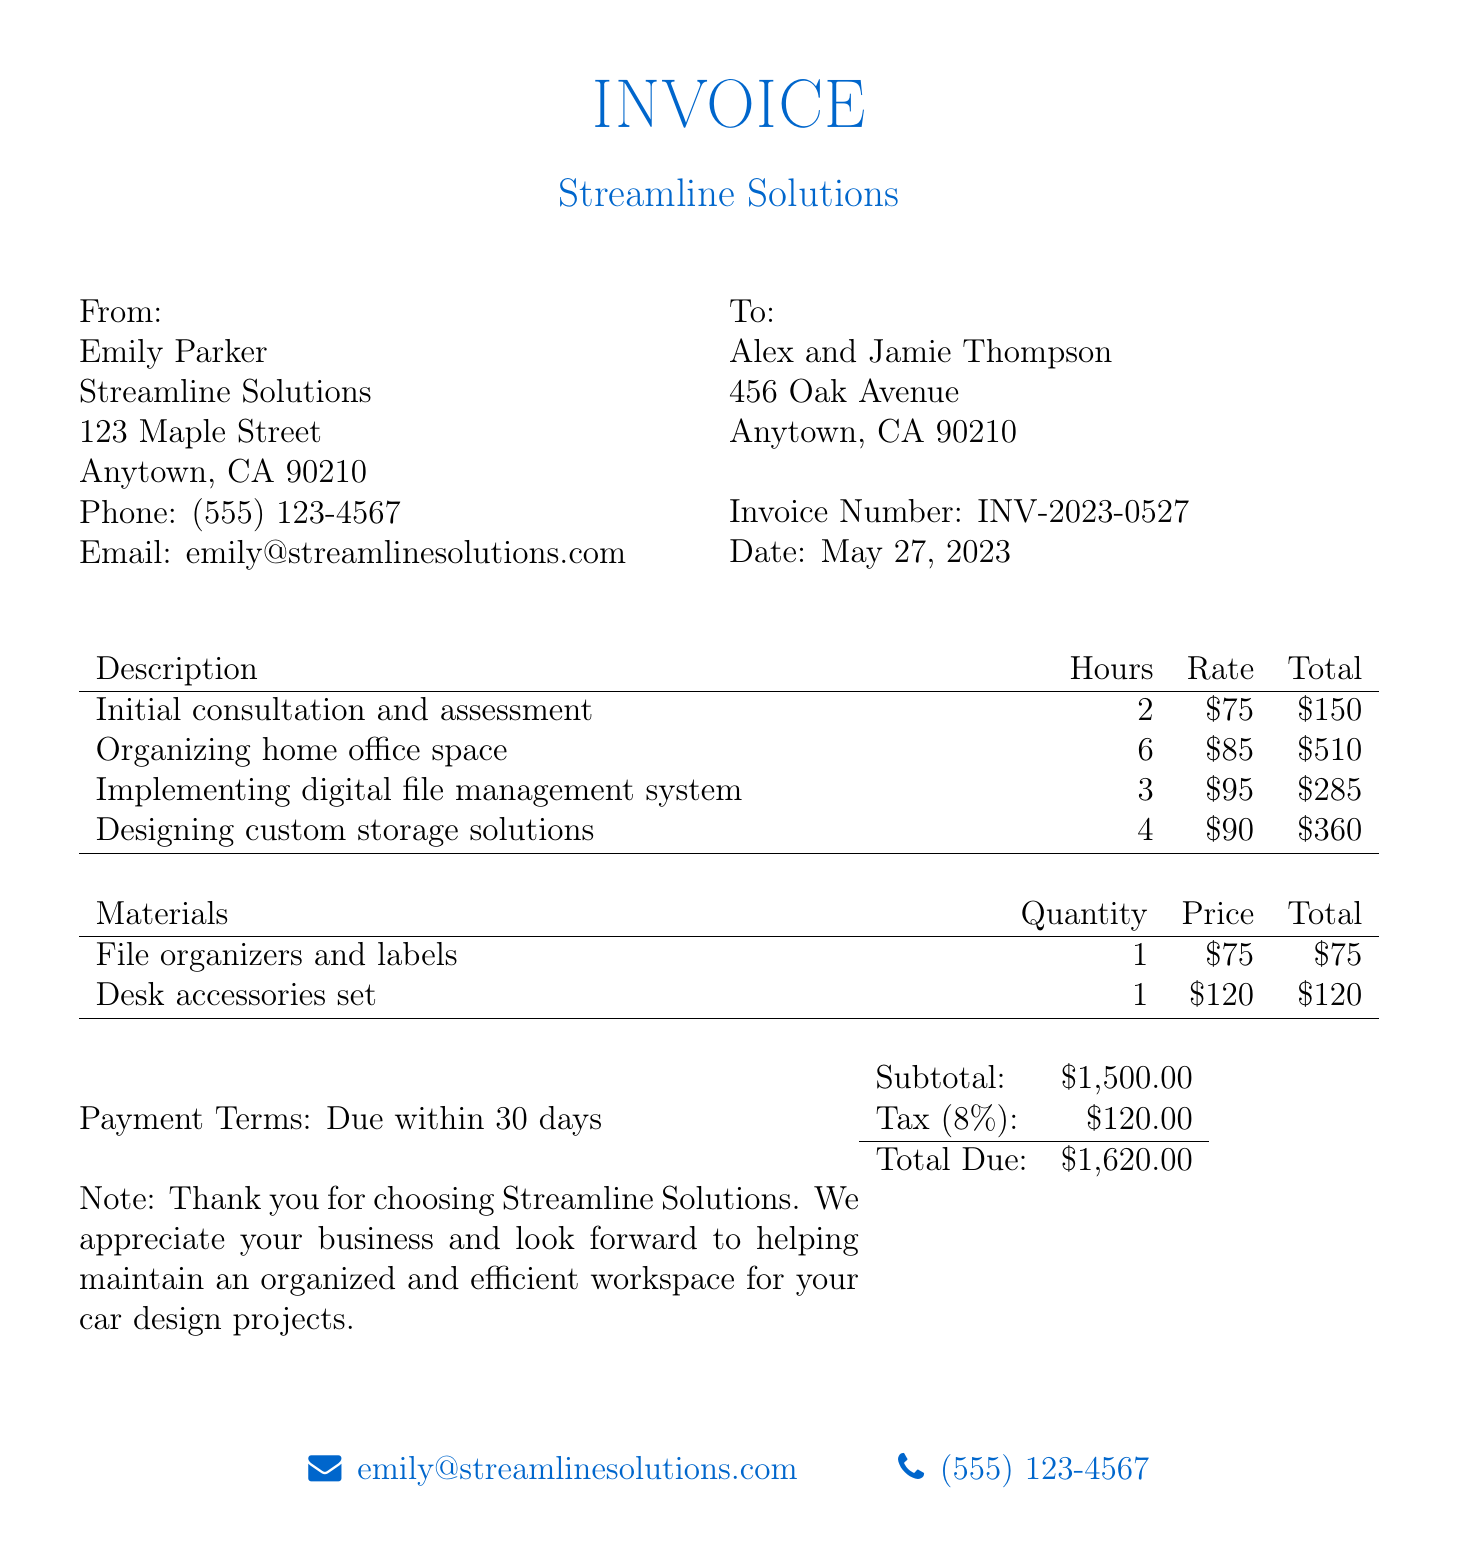What is the invoice number? The invoice number is a unique identifier for the bill, found in the document.
Answer: INV-2023-0527 Who is the service provider? The service provider is the company or individual that provided the organizing services.
Answer: Emily Parker How many hours were spent organizing the home office space? The document provides a breakdown of hours for each service, including organizing the home office.
Answer: 6 What is the total due amount? The total due amount is presented at the end of the invoice and combines all services and materials.
Answer: $1,620.00 What is the rate for implementing a digital file management system? The rate is outlined next to the service description and is part of the pricing details.
Answer: $95 What materials were purchased for organizing? The document lists specific materials that were acquired for the service.
Answer: File organizers and labels, Desk accessories set How much is the tax applied to the invoice? The tax is calculated based on the subtotal and shown in a separate line.
Answer: $120.00 What is the deadline for payment? The payment terms specify the timeline within which payment is expected.
Answer: Due within 30 days How many hours were spent on the initial consultation and assessment? The hours for each service are detailed in the invoice section.
Answer: 2 